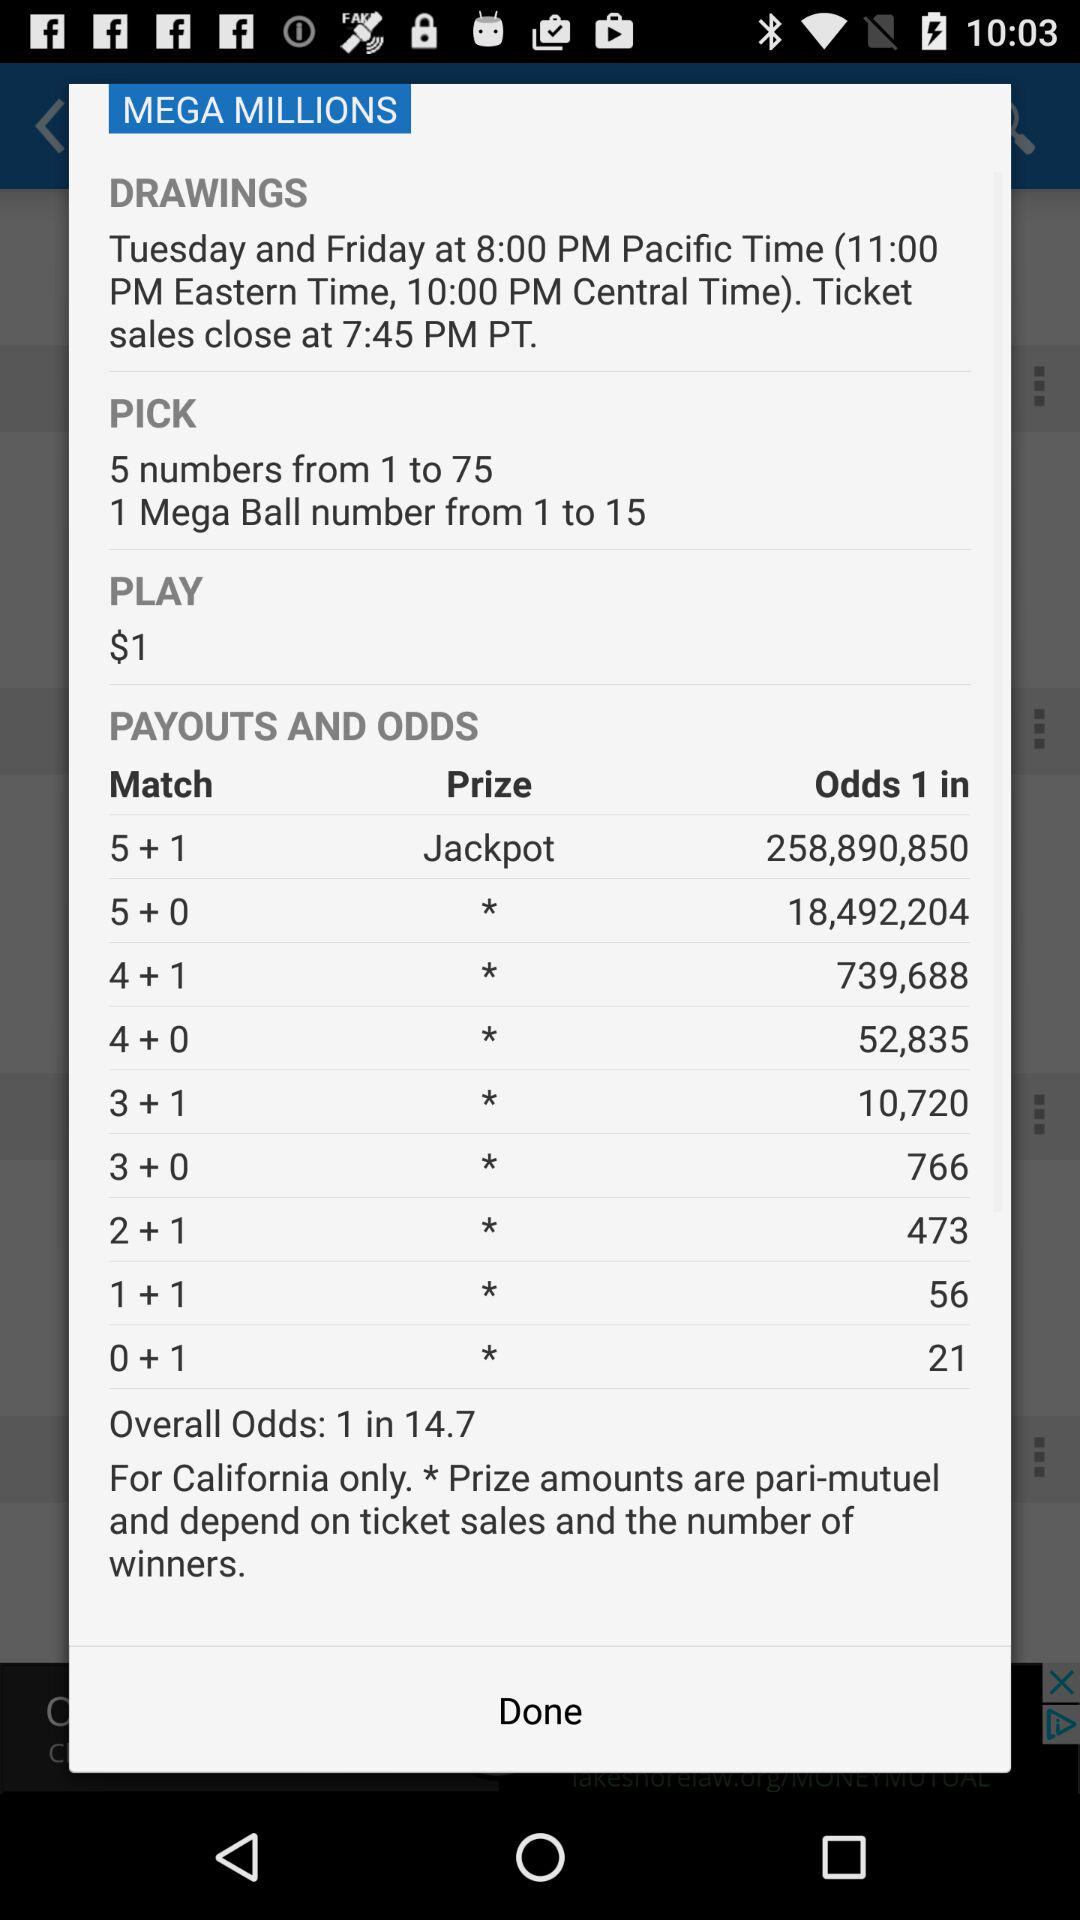What is the minimum number of numbers I need to pick to win a prize?
Answer the question using a single word or phrase. 5 